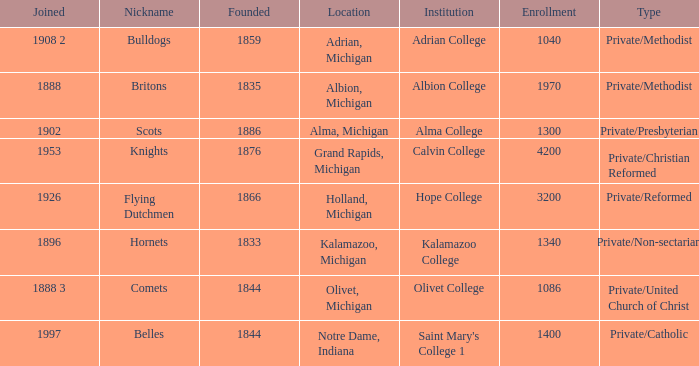Under belles, which is the most possible created? 1844.0. 